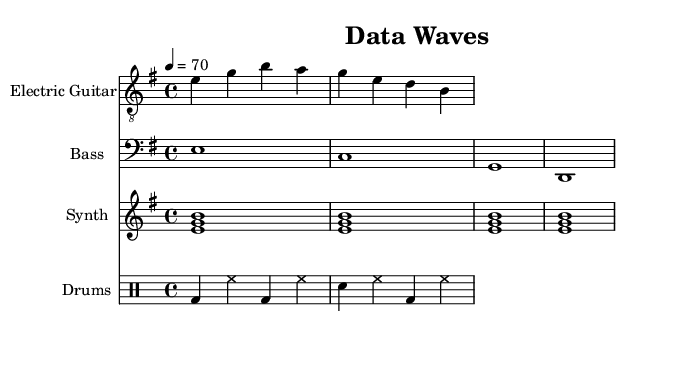What is the key signature of this music? The key signature is indicated at the beginning of the staff, showing that this piece is in E minor, which has one sharp (F#).
Answer: E minor What is the time signature of this music? The time signature is located at the beginning of the score, which indicates that there are four beats per measure and a quarter note gets one beat.
Answer: 4/4 What tempo marking is used in this music? The tempo marking appears at the beginning of the score as "4 = 70," indicating that the quarter note is played at a speed of 70 beats per minute.
Answer: 70 How many measures are there in the electric guitar part? By counting the notated measures in the electric guitar line, I can see there are four bars present, suggesting a complete section.
Answer: 4 Which instrument plays the longest note value? The bass guitar part shows whole notes (e1, c1, g1, d1), indicating that it holds each note for an entire measure, which is longer than the other instruments in this section.
Answer: Bass What is the primary musical texture of this piece? Analyzing the layers of sound, including the electric guitar, bass, synth pad, and drums, it appears to combine harmonic and rhythmic elements typical in post-rock, leading to a rich, layered texture.
Answer: Layered What is the rhythmic pattern of the drums? Observing the drum part, the bass drum (bd) and snare drum (sn) are alternating in a consistent pattern with hi-hats (hh) filling the remaining subdivisions, creating a steady rhythm throughout.
Answer: Steady 